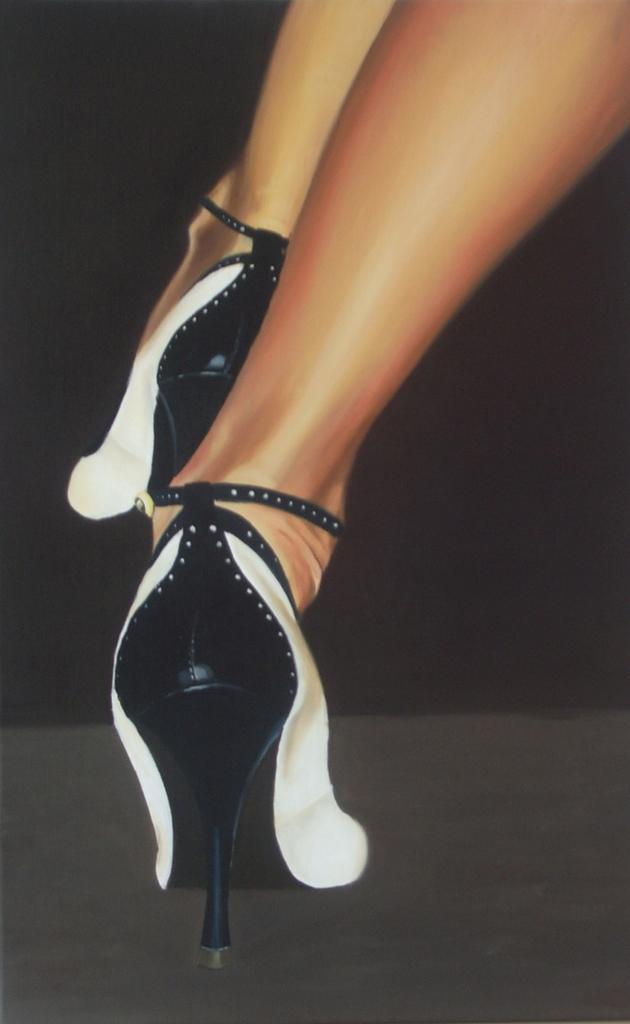Can you describe this image briefly? In this picture, we see the legs of the girl wearing sandals. These sandals are in white and black color. In the background, it is black in color. At the bottom of the picture, it is in dark grey color. 